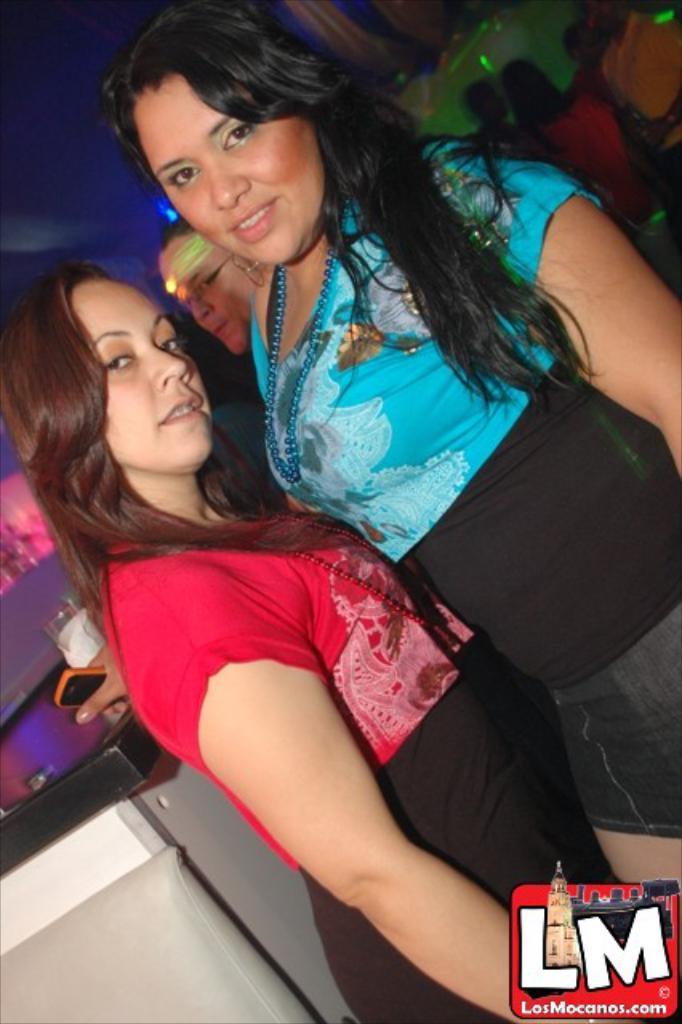Describe this image in one or two sentences. In this image I can see two people with red, blue and black color dress. I can see one person is holding the mobile. In the back there are few more people with different color dresses. And I can see the glass on the table. 